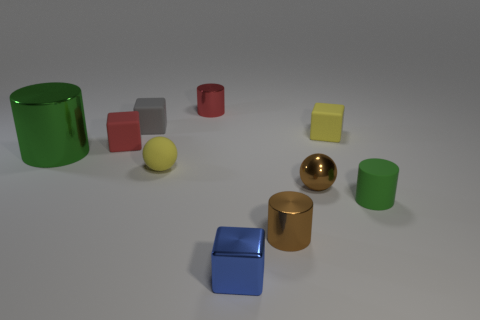Subtract all brown spheres. How many green cylinders are left? 2 Subtract 1 cylinders. How many cylinders are left? 3 Subtract all red cylinders. How many cylinders are left? 3 Subtract all red rubber blocks. How many blocks are left? 3 Subtract all blue cylinders. Subtract all purple spheres. How many cylinders are left? 4 Subtract all cylinders. How many objects are left? 6 Add 2 green shiny objects. How many green shiny objects are left? 3 Add 5 big purple rubber balls. How many big purple rubber balls exist? 5 Subtract 1 brown cylinders. How many objects are left? 9 Subtract all purple objects. Subtract all tiny things. How many objects are left? 1 